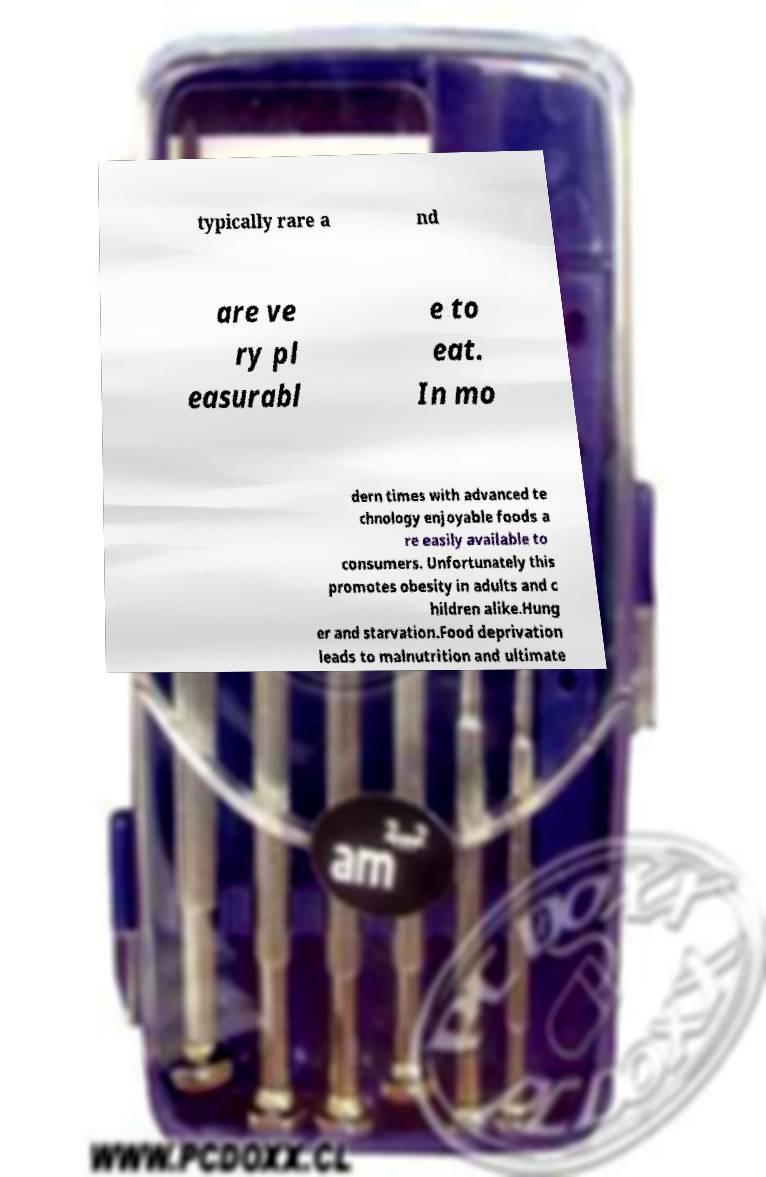For documentation purposes, I need the text within this image transcribed. Could you provide that? typically rare a nd are ve ry pl easurabl e to eat. In mo dern times with advanced te chnology enjoyable foods a re easily available to consumers. Unfortunately this promotes obesity in adults and c hildren alike.Hung er and starvation.Food deprivation leads to malnutrition and ultimate 